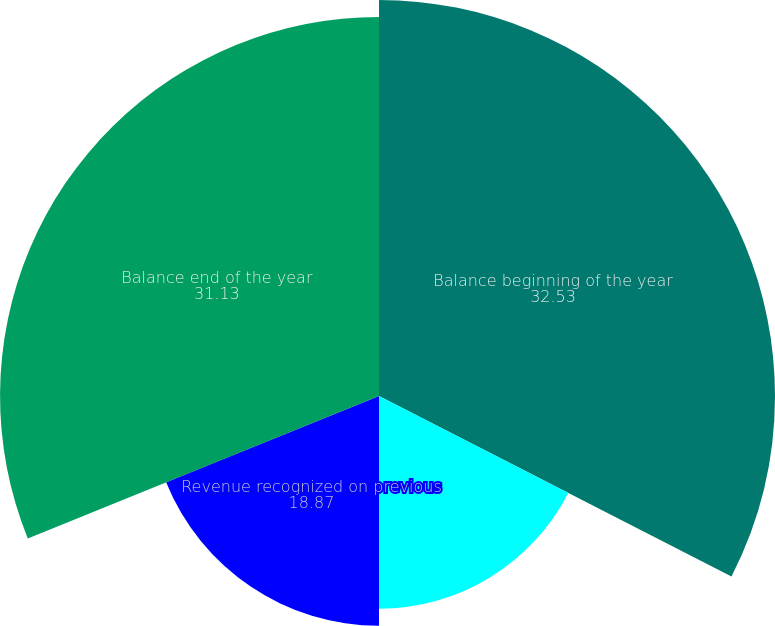Convert chart. <chart><loc_0><loc_0><loc_500><loc_500><pie_chart><fcel>Balance beginning of the year<fcel>Amounts deferred for new<fcel>Revenue recognized on previous<fcel>Balance end of the year<nl><fcel>32.53%<fcel>17.47%<fcel>18.87%<fcel>31.13%<nl></chart> 